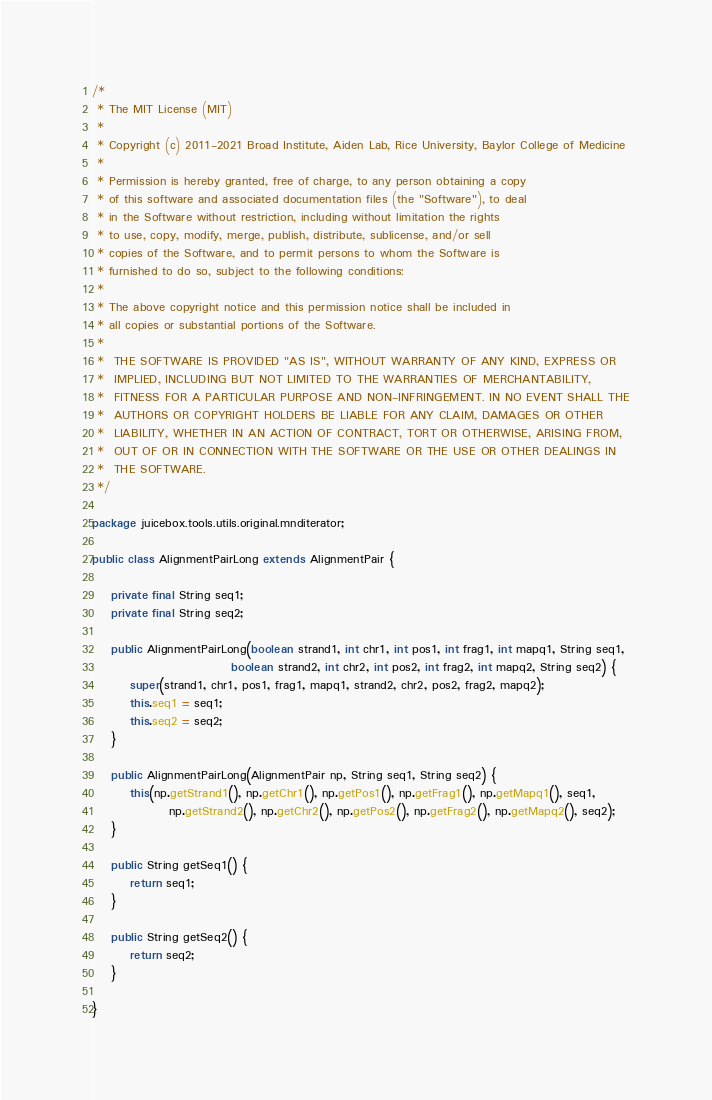Convert code to text. <code><loc_0><loc_0><loc_500><loc_500><_Java_>/*
 * The MIT License (MIT)
 *
 * Copyright (c) 2011-2021 Broad Institute, Aiden Lab, Rice University, Baylor College of Medicine
 *
 * Permission is hereby granted, free of charge, to any person obtaining a copy
 * of this software and associated documentation files (the "Software"), to deal
 * in the Software without restriction, including without limitation the rights
 * to use, copy, modify, merge, publish, distribute, sublicense, and/or sell
 * copies of the Software, and to permit persons to whom the Software is
 * furnished to do so, subject to the following conditions:
 *
 * The above copyright notice and this permission notice shall be included in
 * all copies or substantial portions of the Software.
 *
 *  THE SOFTWARE IS PROVIDED "AS IS", WITHOUT WARRANTY OF ANY KIND, EXPRESS OR
 *  IMPLIED, INCLUDING BUT NOT LIMITED TO THE WARRANTIES OF MERCHANTABILITY,
 *  FITNESS FOR A PARTICULAR PURPOSE AND NON-INFRINGEMENT. IN NO EVENT SHALL THE
 *  AUTHORS OR COPYRIGHT HOLDERS BE LIABLE FOR ANY CLAIM, DAMAGES OR OTHER
 *  LIABILITY, WHETHER IN AN ACTION OF CONTRACT, TORT OR OTHERWISE, ARISING FROM,
 *  OUT OF OR IN CONNECTION WITH THE SOFTWARE OR THE USE OR OTHER DEALINGS IN
 *  THE SOFTWARE.
 */

package juicebox.tools.utils.original.mnditerator;

public class AlignmentPairLong extends AlignmentPair {

    private final String seq1;
    private final String seq2;

    public AlignmentPairLong(boolean strand1, int chr1, int pos1, int frag1, int mapq1, String seq1,
                             boolean strand2, int chr2, int pos2, int frag2, int mapq2, String seq2) {
        super(strand1, chr1, pos1, frag1, mapq1, strand2, chr2, pos2, frag2, mapq2);
        this.seq1 = seq1;
        this.seq2 = seq2;
    }

    public AlignmentPairLong(AlignmentPair np, String seq1, String seq2) {
        this(np.getStrand1(), np.getChr1(), np.getPos1(), np.getFrag1(), np.getMapq1(), seq1,
                np.getStrand2(), np.getChr2(), np.getPos2(), np.getFrag2(), np.getMapq2(), seq2);
    }

    public String getSeq1() {
        return seq1;
    }

    public String getSeq2() {
        return seq2;
    }

}

</code> 